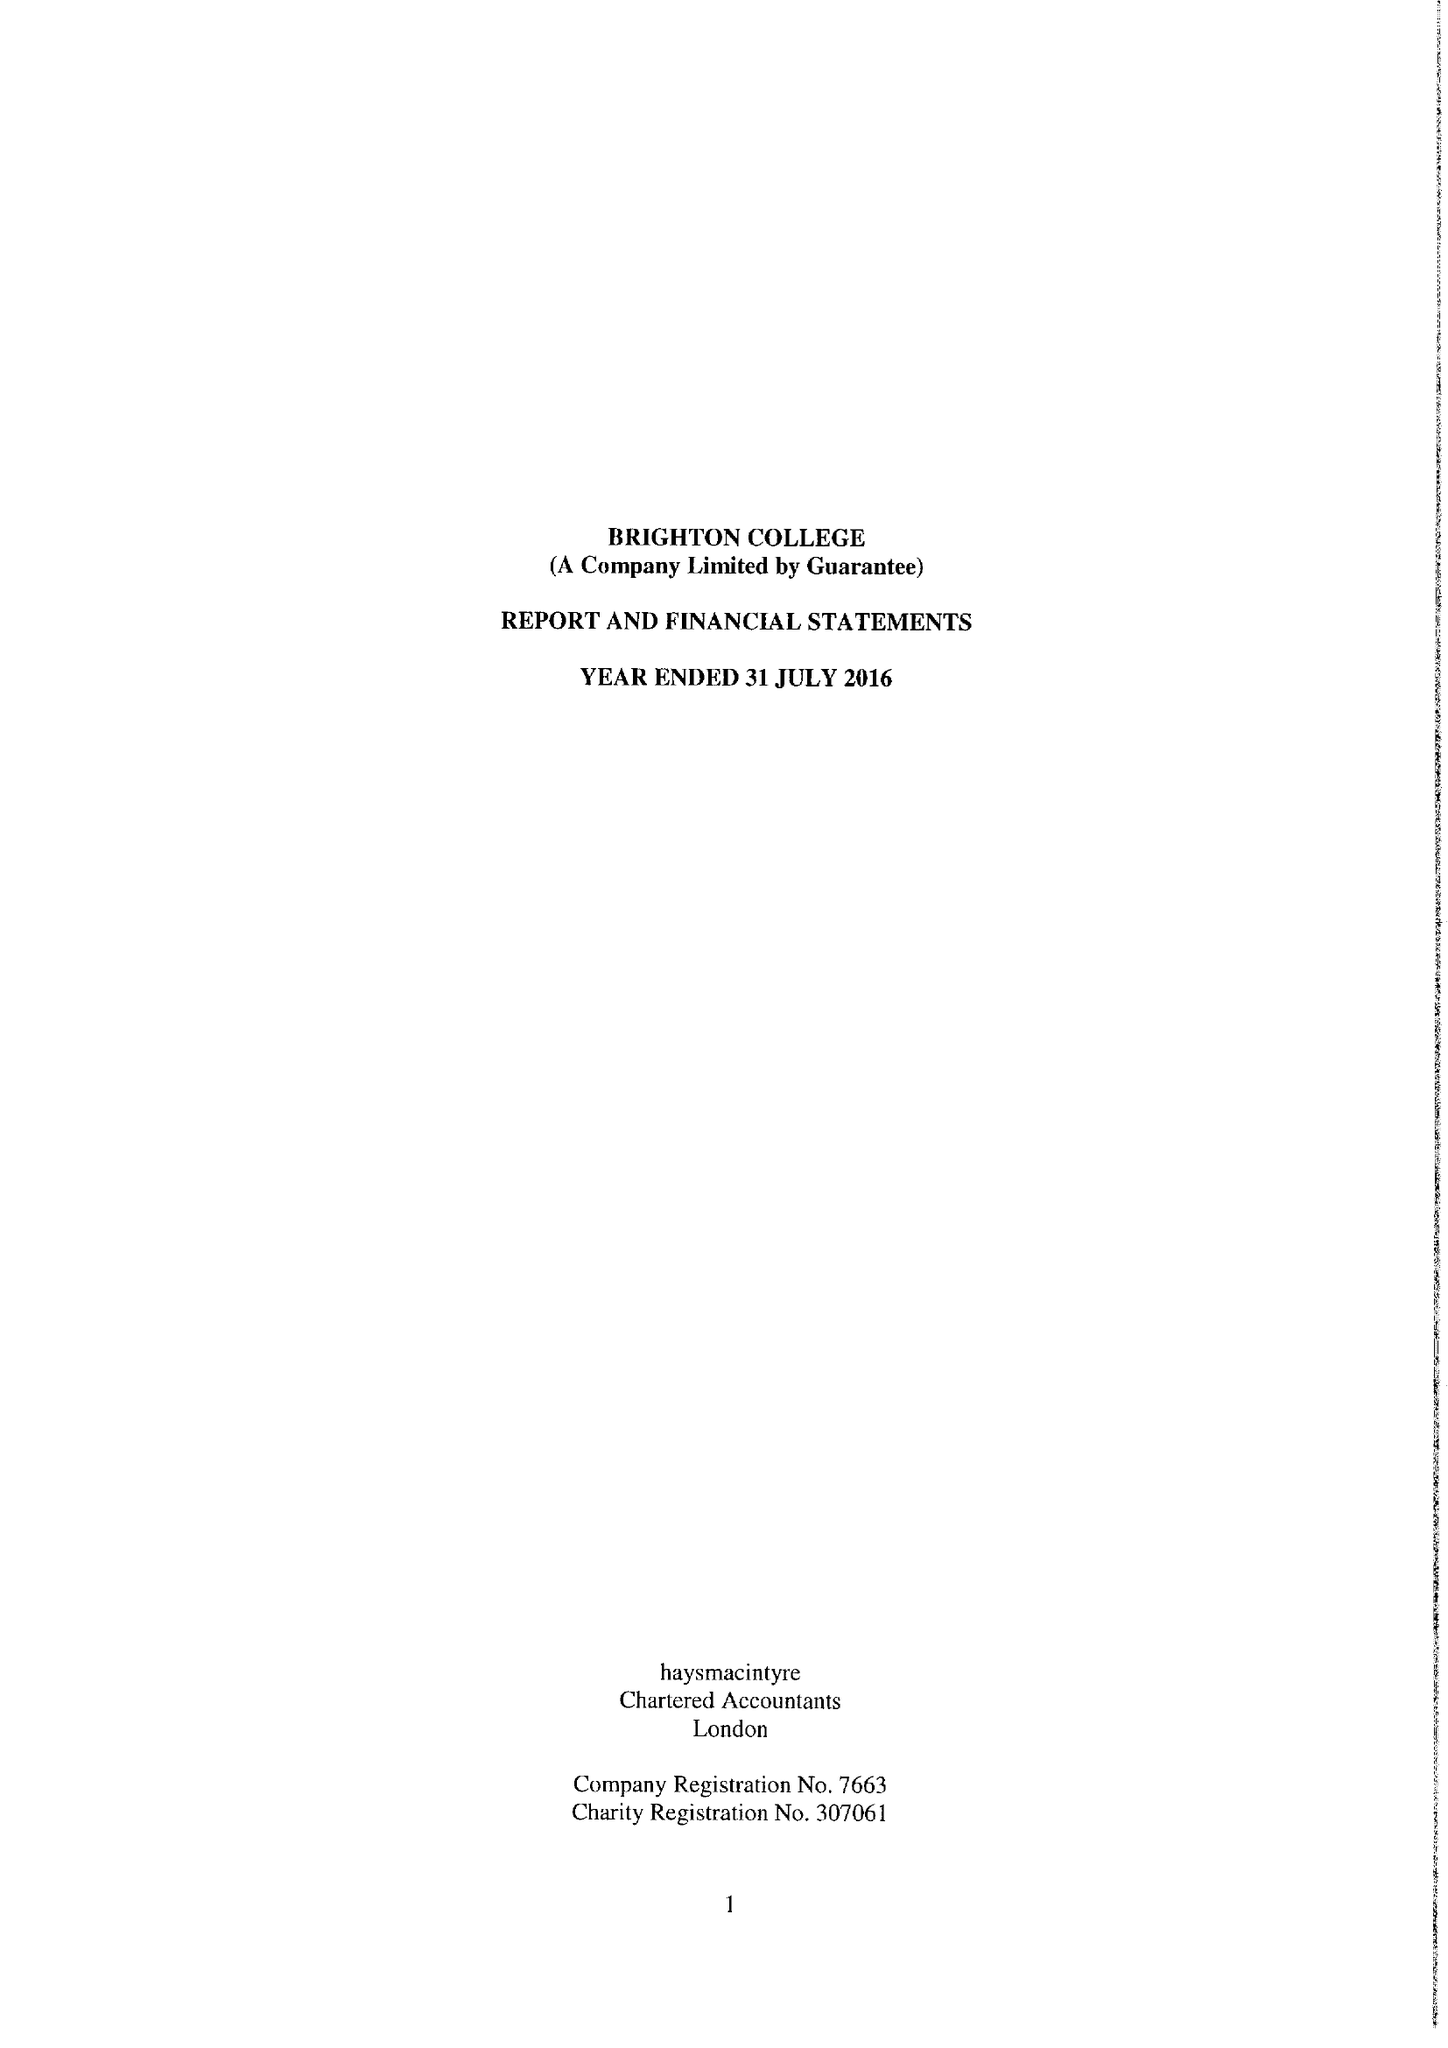What is the value for the address__postcode?
Answer the question using a single word or phrase. BN2 0AL 